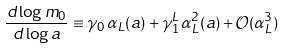Convert formula to latex. <formula><loc_0><loc_0><loc_500><loc_500>\frac { d \log m _ { 0 } } { d \log a } \equiv \gamma _ { 0 } \, \alpha _ { L } ( a ) + \gamma _ { 1 } ^ { L } \, \alpha _ { L } ^ { 2 } ( a ) + \mathcal { O } ( \alpha _ { L } ^ { 3 } )</formula> 